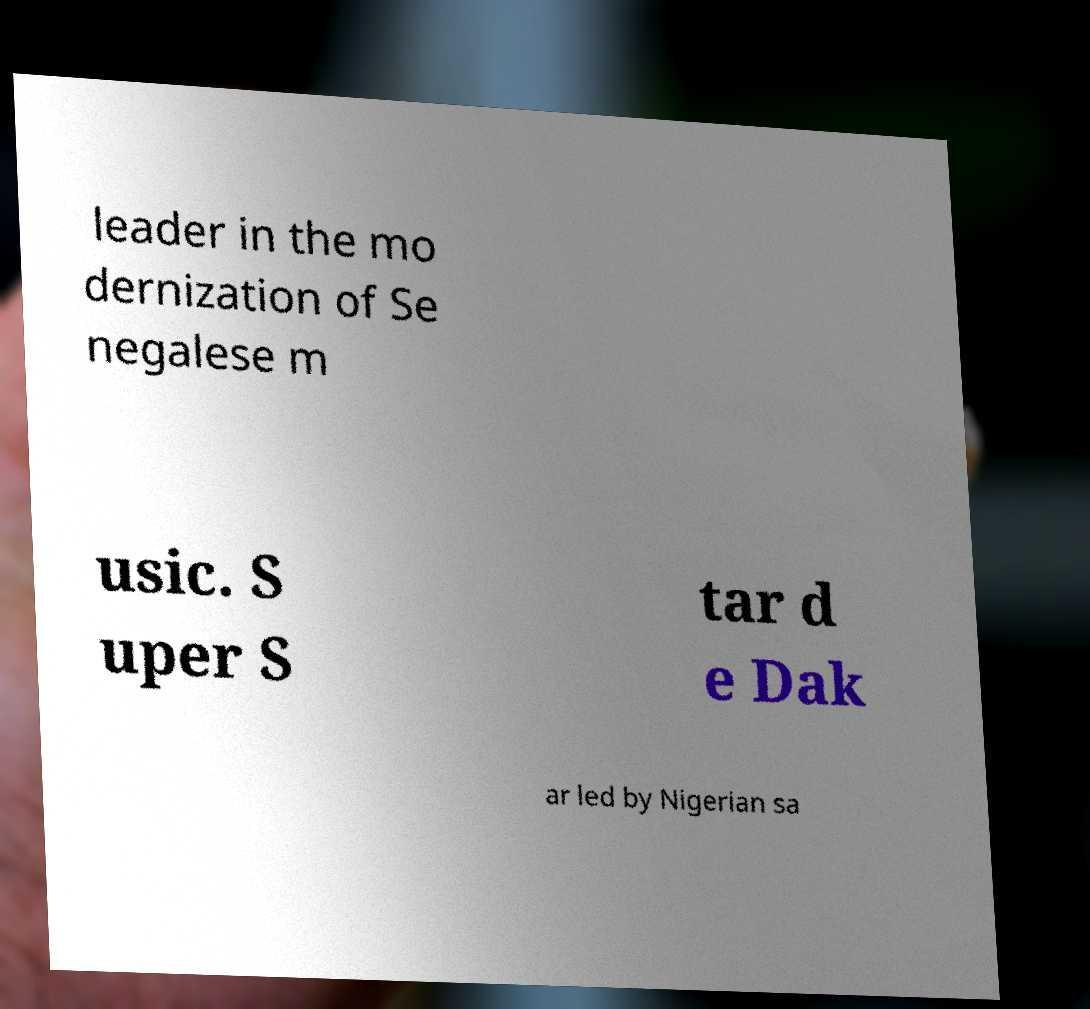I need the written content from this picture converted into text. Can you do that? leader in the mo dernization of Se negalese m usic. S uper S tar d e Dak ar led by Nigerian sa 